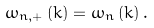Convert formula to latex. <formula><loc_0><loc_0><loc_500><loc_500>\omega _ { n , + } \left ( k \right ) = \omega _ { n } \left ( k \right ) .</formula> 